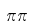<formula> <loc_0><loc_0><loc_500><loc_500>\pi \pi</formula> 